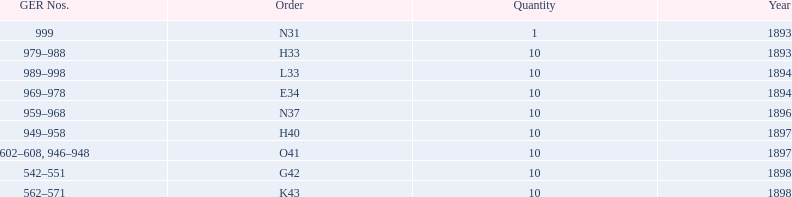How mans years have ger nos below 900? 2. 